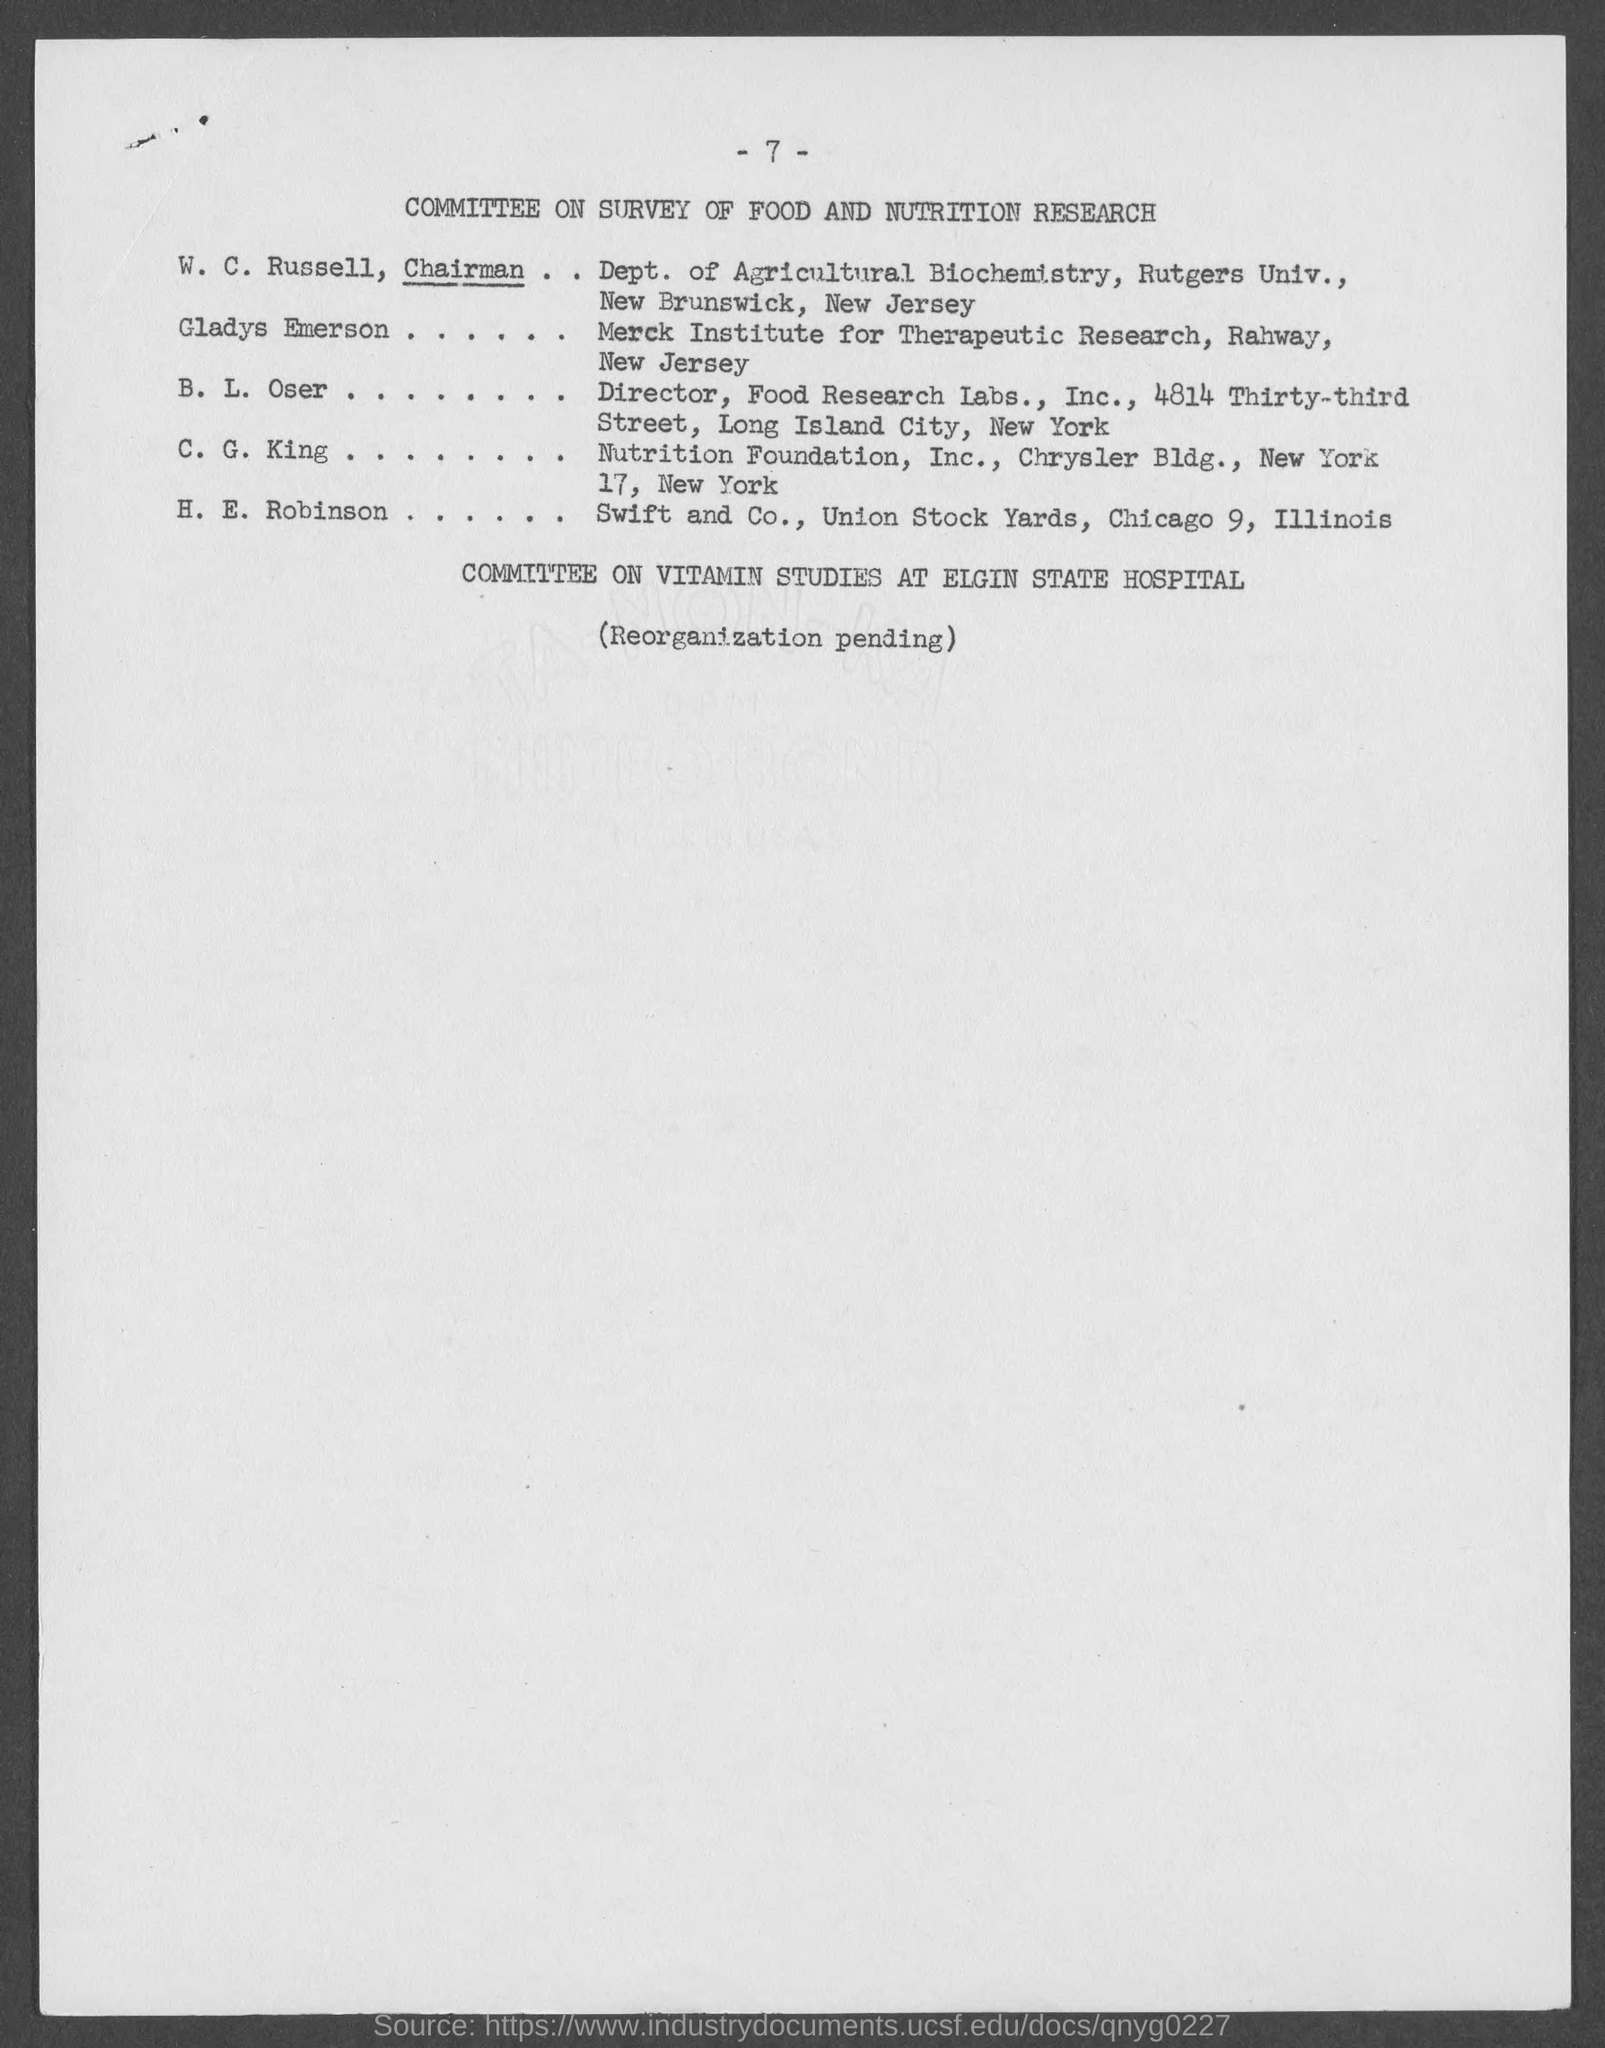List a handful of essential elements in this visual. The individual who holds the position of Chairman in the Department of Agricultural Biochemistry is W. C. Russell. The Nutrition Foundation Inc. can be found at Chrysler Building, 17 New York, New York. The title of the page is the Committee on Survey of Food and Nutrition Research. Gladys Emerson belongs to the Merck Institute for Therapeutic Research. Swift and Co. is located at the address of the Union stock yards in Chicago, Illinois. The address is 9. 